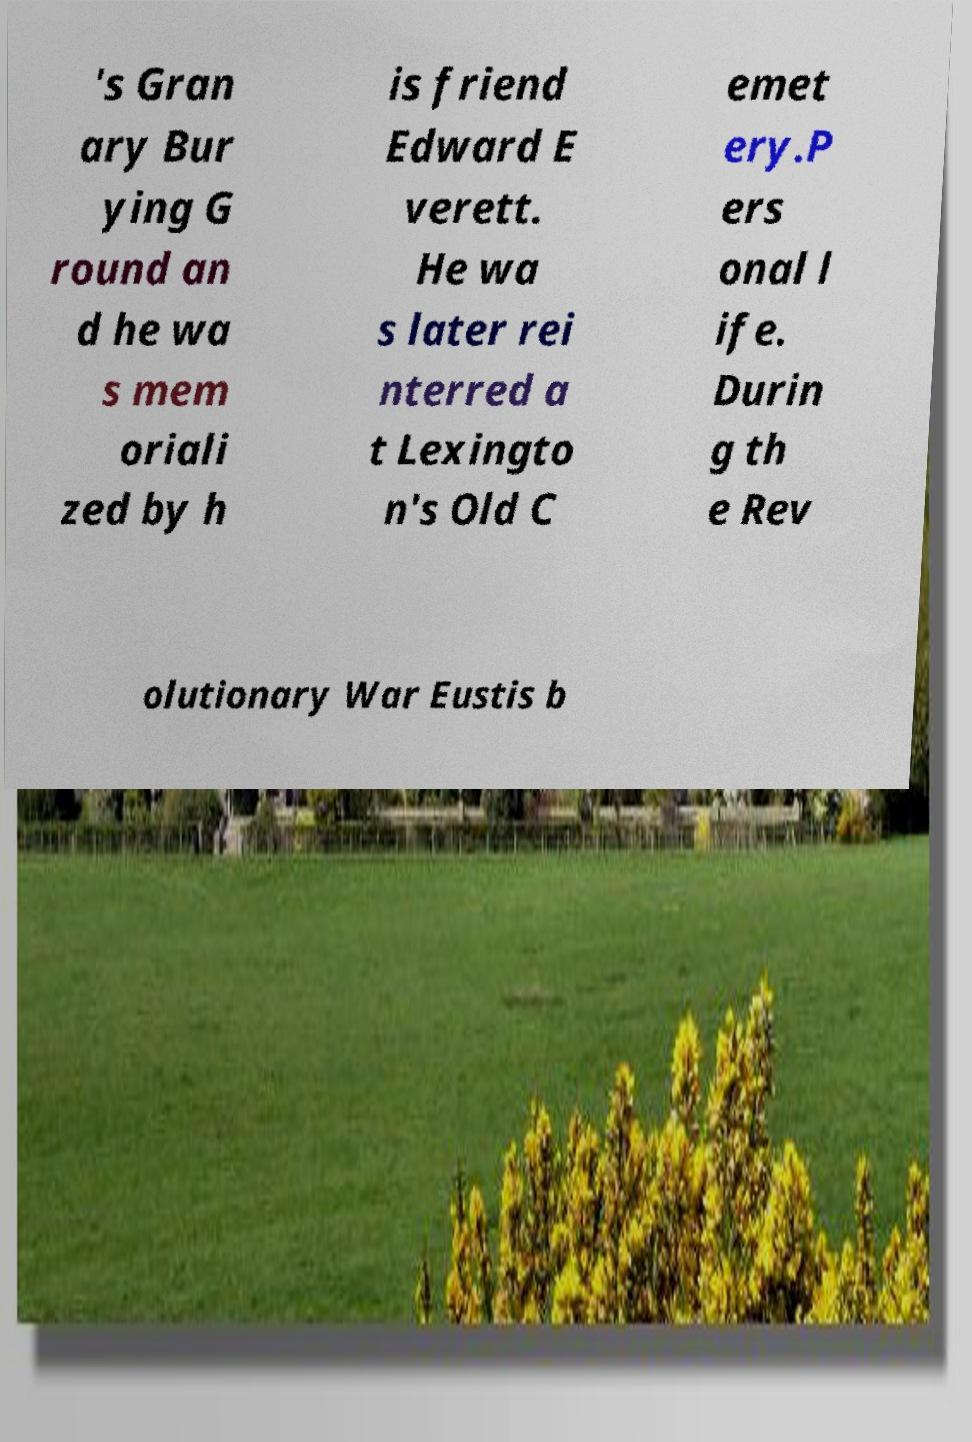Can you accurately transcribe the text from the provided image for me? 's Gran ary Bur ying G round an d he wa s mem oriali zed by h is friend Edward E verett. He wa s later rei nterred a t Lexingto n's Old C emet ery.P ers onal l ife. Durin g th e Rev olutionary War Eustis b 